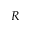Convert formula to latex. <formula><loc_0><loc_0><loc_500><loc_500>R</formula> 